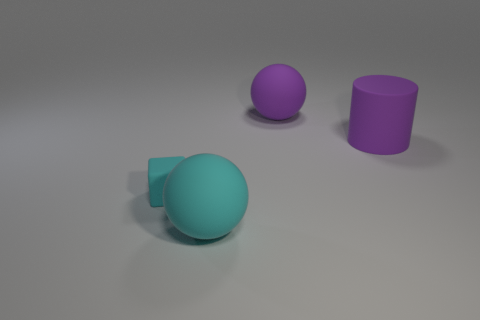What shape is the large thing that is the same color as the small rubber thing?
Make the answer very short. Sphere. There is a cylinder; is its color the same as the large sphere that is behind the small cyan matte block?
Your answer should be compact. Yes. There is a ball that is the same color as the cylinder; what size is it?
Your answer should be compact. Large. How many other things are there of the same shape as the tiny cyan matte object?
Ensure brevity in your answer.  0. Are there any other things that have the same size as the cyan cube?
Ensure brevity in your answer.  No. The cyan thing that is behind the big ball in front of the cylinder is what shape?
Provide a short and direct response. Cube. Are there fewer purple matte balls than rubber balls?
Your answer should be compact. Yes. There is a thing that is both on the right side of the tiny matte block and in front of the rubber cylinder; what is its size?
Give a very brief answer. Large. Does the purple sphere have the same size as the purple cylinder?
Provide a succinct answer. Yes. There is a large matte ball in front of the tiny matte block; does it have the same color as the cube?
Keep it short and to the point. Yes. 